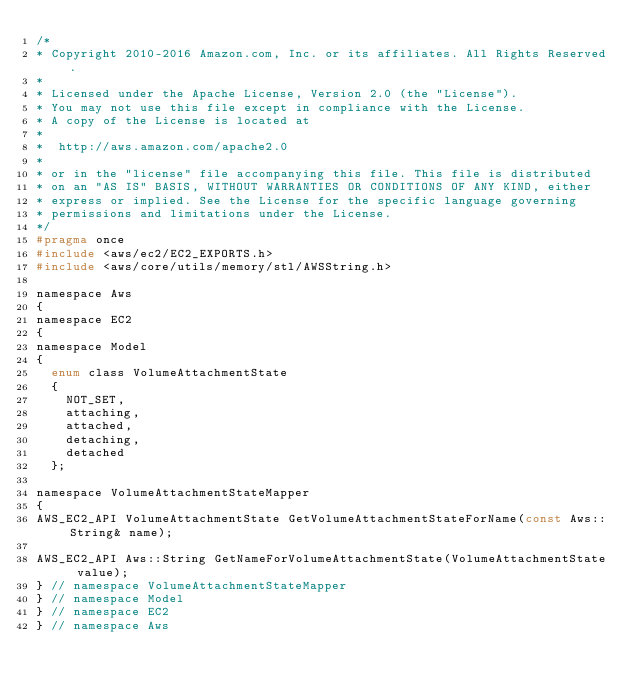Convert code to text. <code><loc_0><loc_0><loc_500><loc_500><_C_>/*
* Copyright 2010-2016 Amazon.com, Inc. or its affiliates. All Rights Reserved.
*
* Licensed under the Apache License, Version 2.0 (the "License").
* You may not use this file except in compliance with the License.
* A copy of the License is located at
*
*  http://aws.amazon.com/apache2.0
*
* or in the "license" file accompanying this file. This file is distributed
* on an "AS IS" BASIS, WITHOUT WARRANTIES OR CONDITIONS OF ANY KIND, either
* express or implied. See the License for the specific language governing
* permissions and limitations under the License.
*/
#pragma once
#include <aws/ec2/EC2_EXPORTS.h>
#include <aws/core/utils/memory/stl/AWSString.h>

namespace Aws
{
namespace EC2
{
namespace Model
{
  enum class VolumeAttachmentState
  {
    NOT_SET,
    attaching,
    attached,
    detaching,
    detached
  };

namespace VolumeAttachmentStateMapper
{
AWS_EC2_API VolumeAttachmentState GetVolumeAttachmentStateForName(const Aws::String& name);

AWS_EC2_API Aws::String GetNameForVolumeAttachmentState(VolumeAttachmentState value);
} // namespace VolumeAttachmentStateMapper
} // namespace Model
} // namespace EC2
} // namespace Aws
</code> 